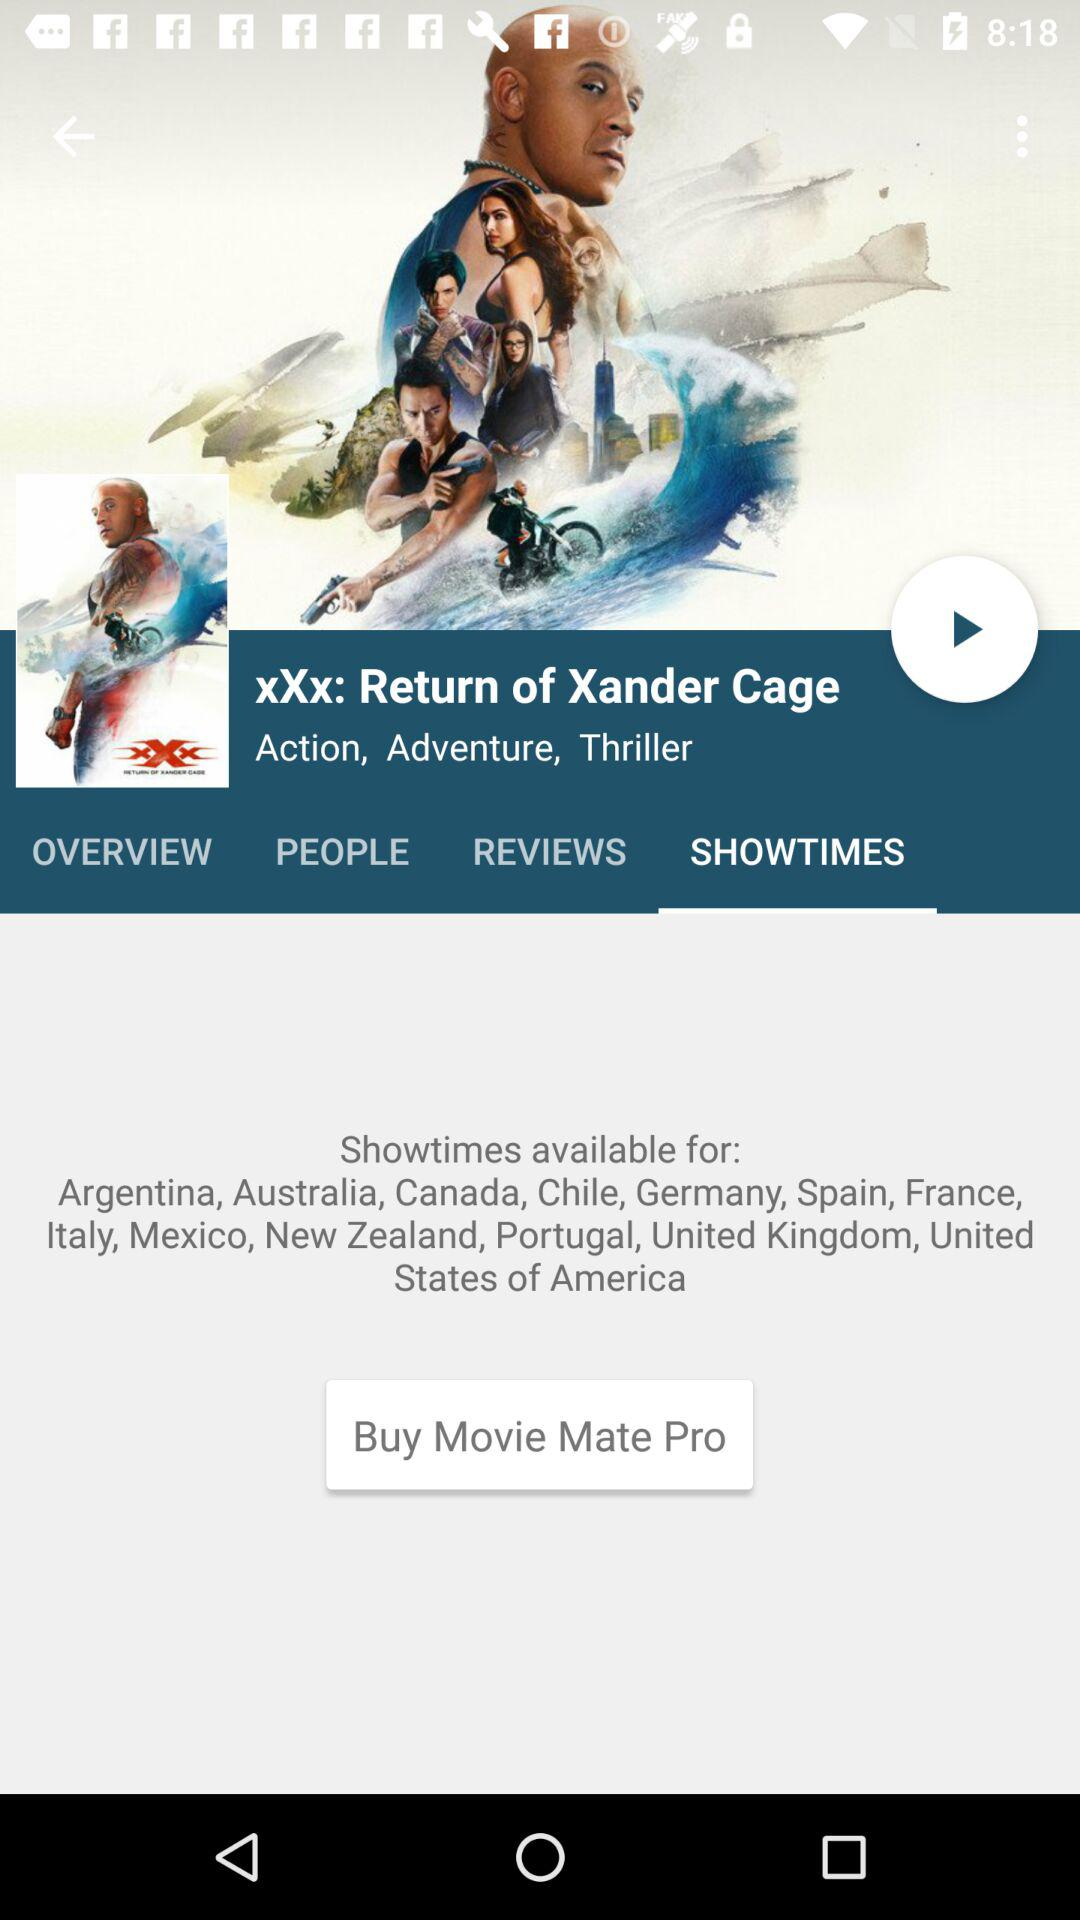Which tab is selected? The selected tab is "SHOWTIMES". 